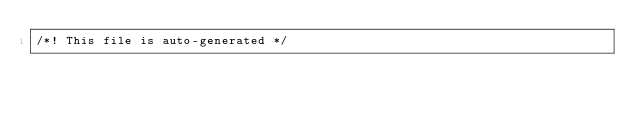Convert code to text. <code><loc_0><loc_0><loc_500><loc_500><_JavaScript_>/*! This file is auto-generated */</code> 